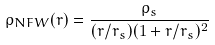<formula> <loc_0><loc_0><loc_500><loc_500>\rho _ { N F W } ( r ) = \frac { \rho _ { s } } { ( r / r _ { s } ) ( 1 + r / r _ { s } ) ^ { 2 } }</formula> 